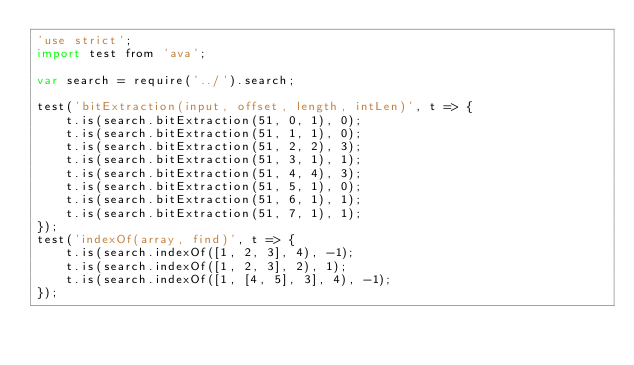<code> <loc_0><loc_0><loc_500><loc_500><_JavaScript_>'use strict';
import test from 'ava';

var search = require('../').search;

test('bitExtraction(input, offset, length, intLen)', t => {
    t.is(search.bitExtraction(51, 0, 1), 0);
    t.is(search.bitExtraction(51, 1, 1), 0);
    t.is(search.bitExtraction(51, 2, 2), 3);
    t.is(search.bitExtraction(51, 3, 1), 1);
    t.is(search.bitExtraction(51, 4, 4), 3);
    t.is(search.bitExtraction(51, 5, 1), 0);
    t.is(search.bitExtraction(51, 6, 1), 1);
    t.is(search.bitExtraction(51, 7, 1), 1);
});
test('indexOf(array, find)', t => {
    t.is(search.indexOf([1, 2, 3], 4), -1);
    t.is(search.indexOf([1, 2, 3], 2), 1);
    t.is(search.indexOf([1, [4, 5], 3], 4), -1);
});
</code> 